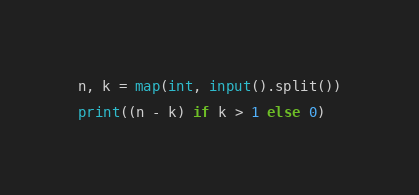<code> <loc_0><loc_0><loc_500><loc_500><_Python_>n, k = map(int, input().split())

print((n - k) if k > 1 else 0)
</code> 